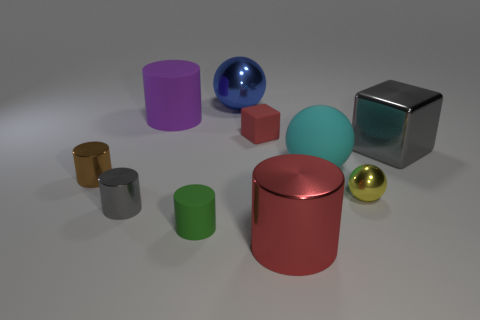Subtract all gray cylinders. How many cylinders are left? 4 Subtract all brown cylinders. How many cylinders are left? 4 Subtract all yellow spheres. Subtract all red blocks. How many spheres are left? 2 Subtract all blocks. How many objects are left? 8 Subtract 0 yellow cylinders. How many objects are left? 10 Subtract all gray matte cylinders. Subtract all shiny cubes. How many objects are left? 9 Add 6 large matte balls. How many large matte balls are left? 7 Add 1 cyan spheres. How many cyan spheres exist? 2 